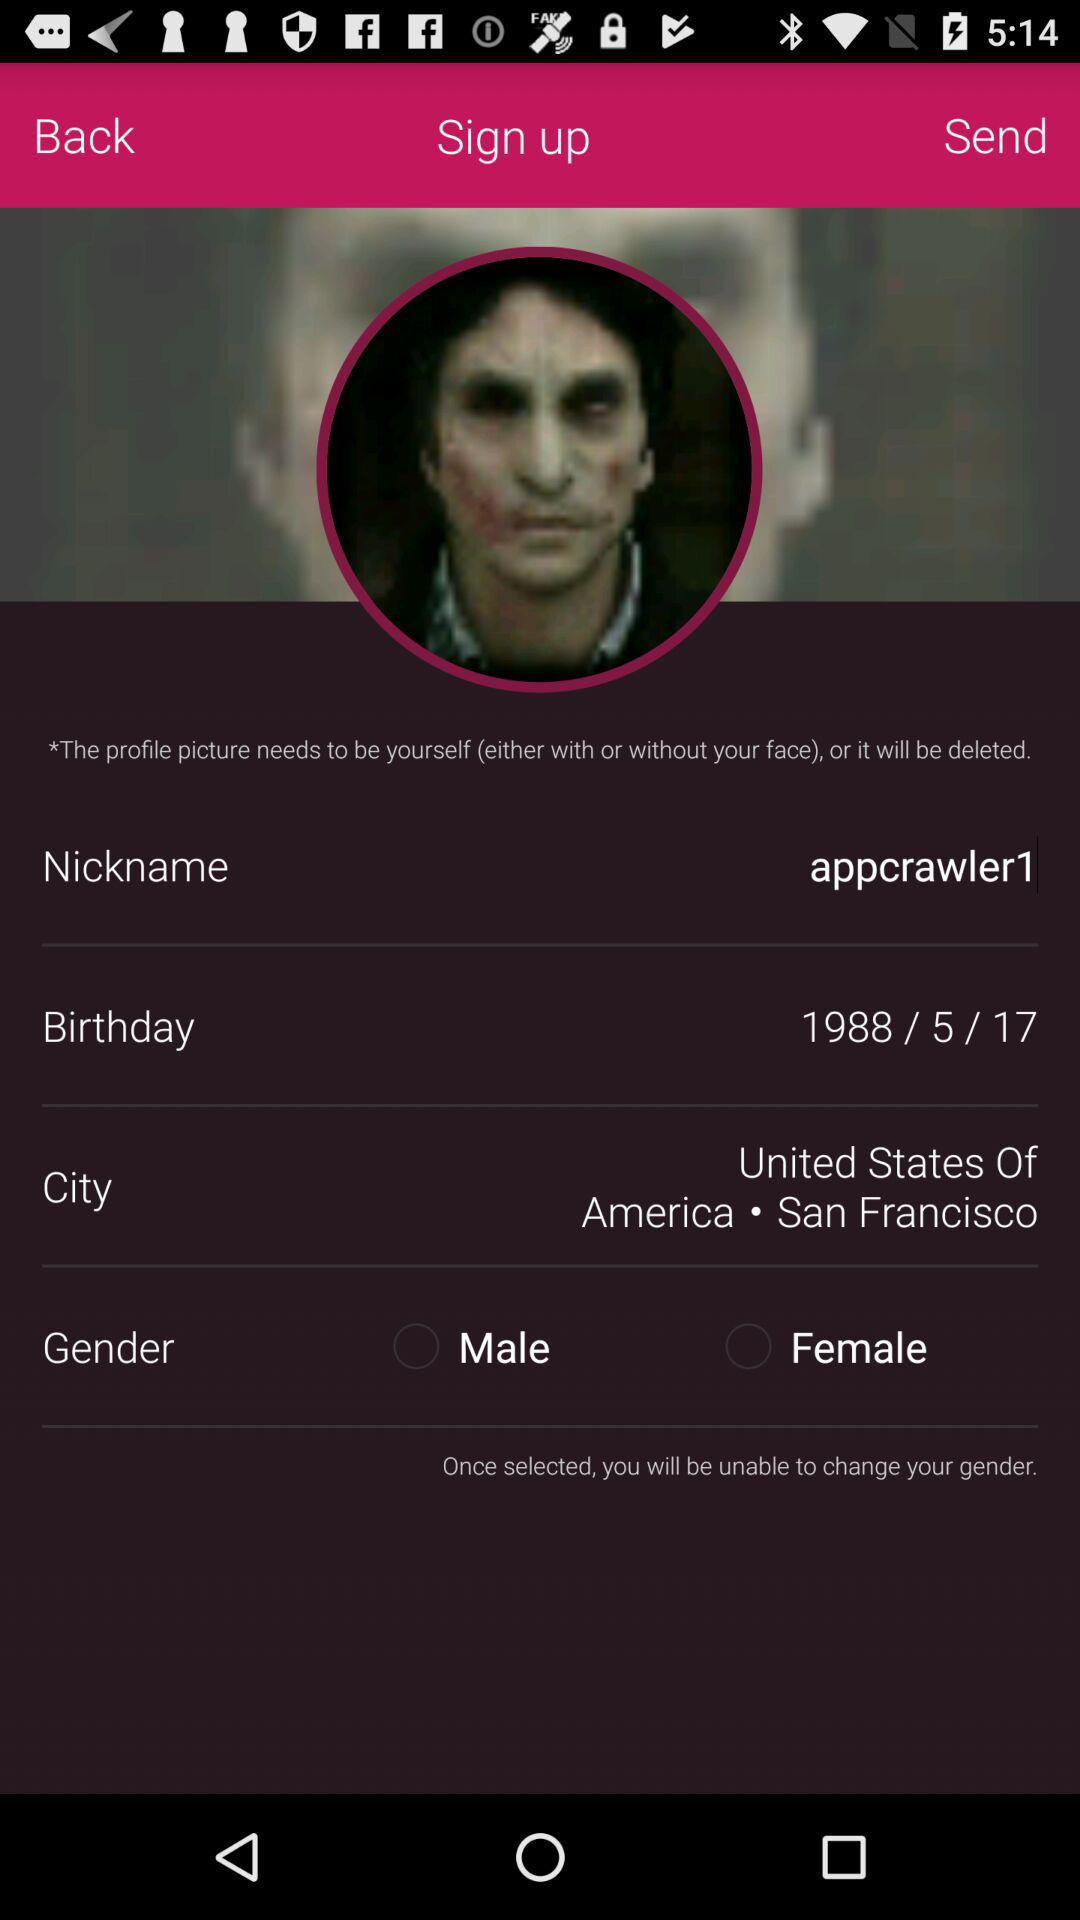What is the nickname? The nickname is "appcrawler". 